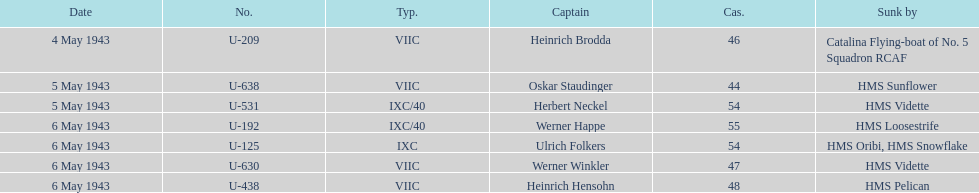Which ship sunk the most u-boats HMS Vidette. 